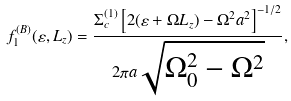<formula> <loc_0><loc_0><loc_500><loc_500>f _ { 1 } ^ { ( B ) } ( \varepsilon , L _ { z } ) = \frac { \Sigma _ { c } ^ { ( 1 ) } \left [ 2 ( \varepsilon + \Omega L _ { z } ) - \Omega ^ { 2 } a ^ { 2 } \right ] ^ { - 1 / 2 } } { 2 \pi a \sqrt { \Omega _ { 0 } ^ { 2 } - \Omega ^ { 2 } } } ,</formula> 